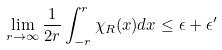<formula> <loc_0><loc_0><loc_500><loc_500>\lim _ { r \rightarrow \infty } \frac { 1 } { 2 r } \int _ { - r } ^ { r } \chi _ { R } ( x ) d x \leq \epsilon + \epsilon ^ { \prime }</formula> 